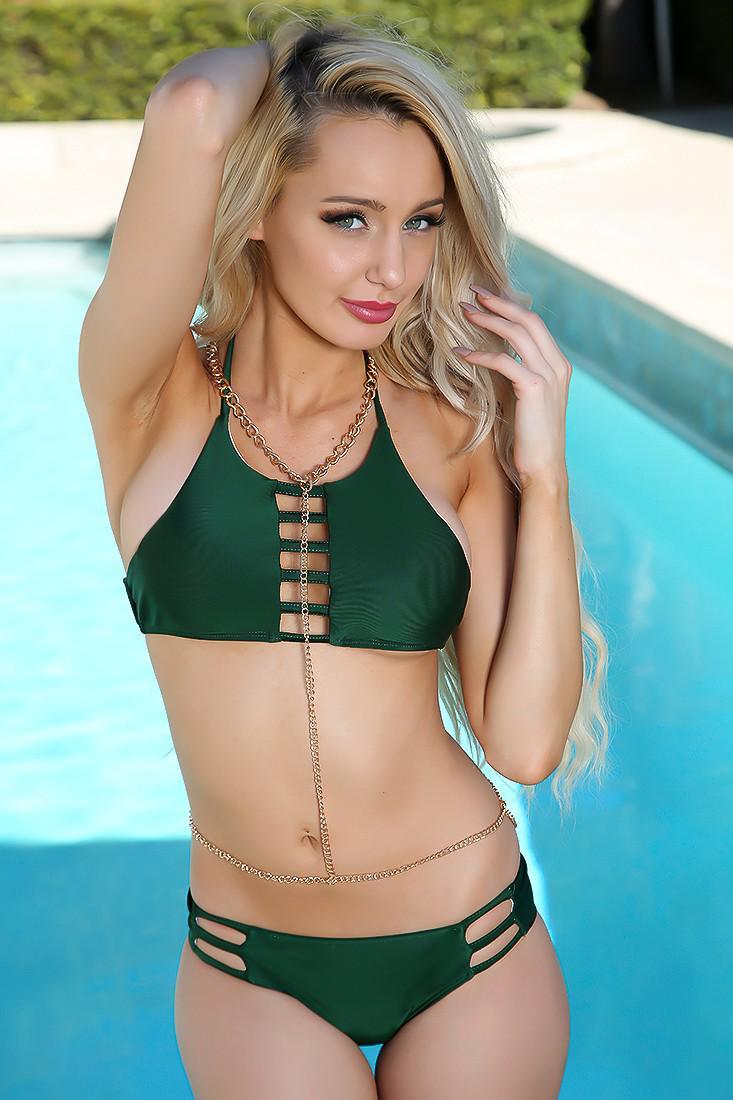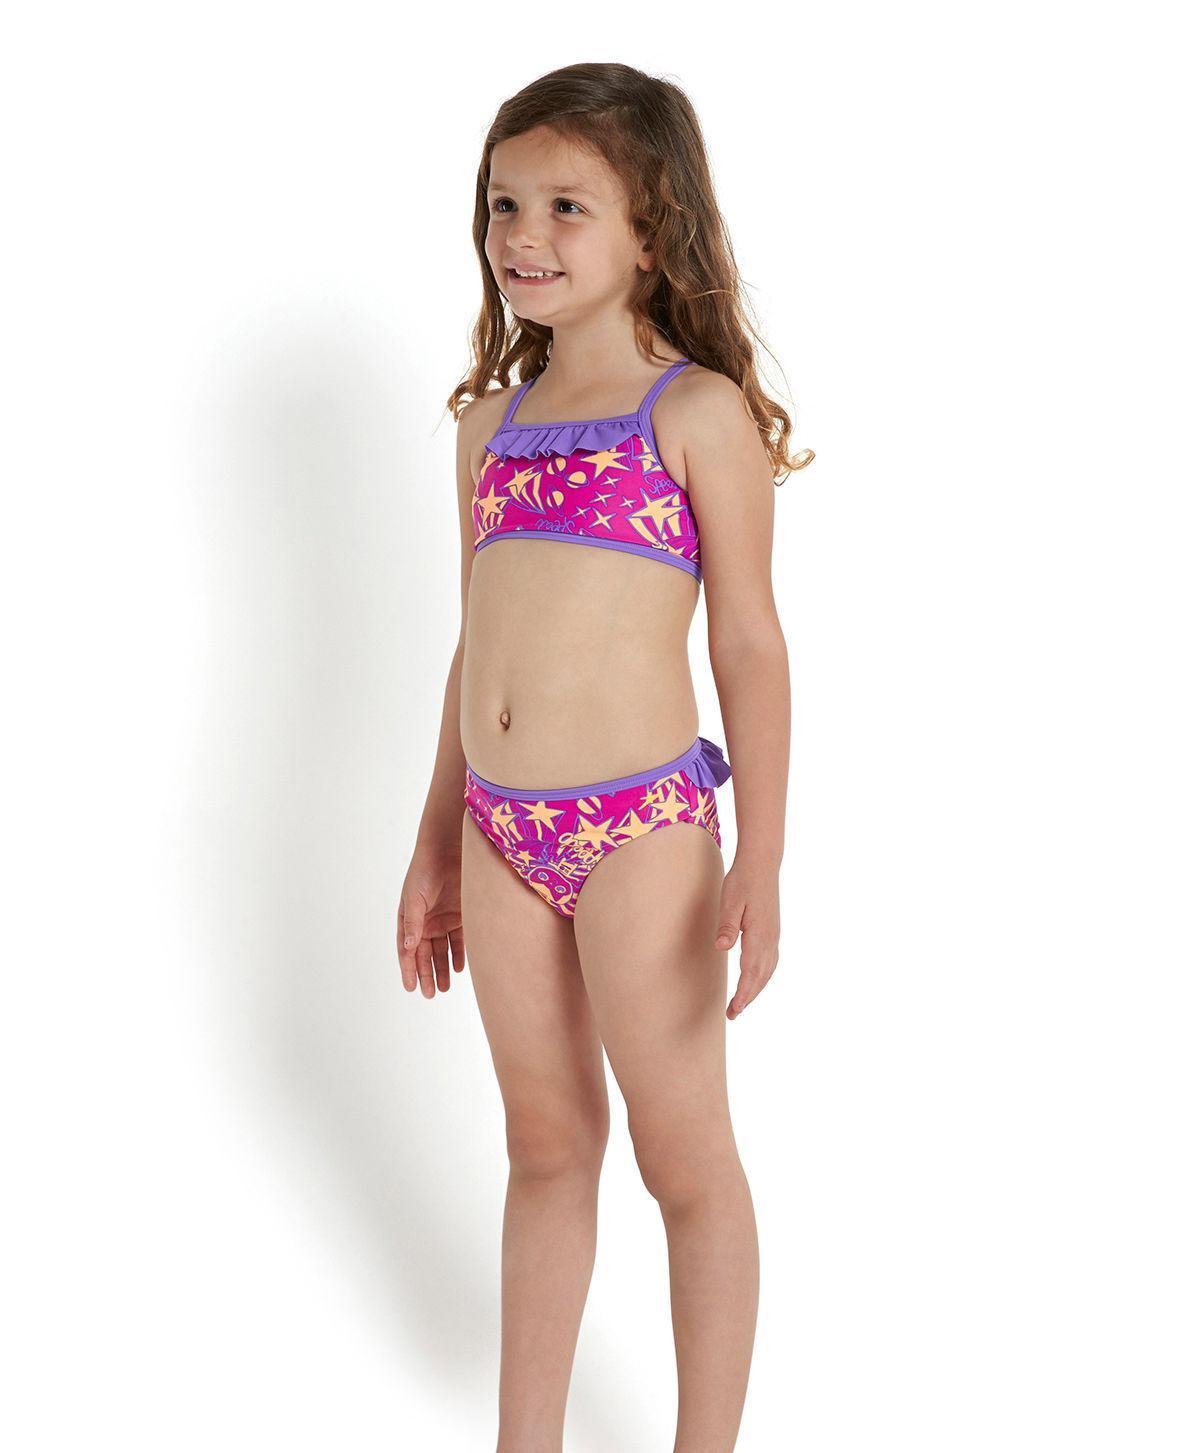The first image is the image on the left, the second image is the image on the right. Evaluate the accuracy of this statement regarding the images: "You can see a swimming pool behind at least one of the models.". Is it true? Answer yes or no. Yes. 